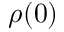Convert formula to latex. <formula><loc_0><loc_0><loc_500><loc_500>\rho ( 0 )</formula> 